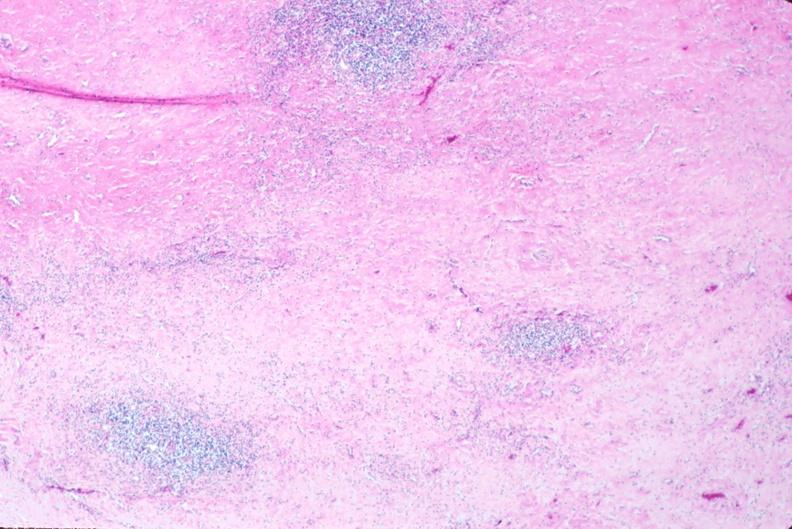what does this image show?
Answer the question using a single word or phrase. Lymph nodes 